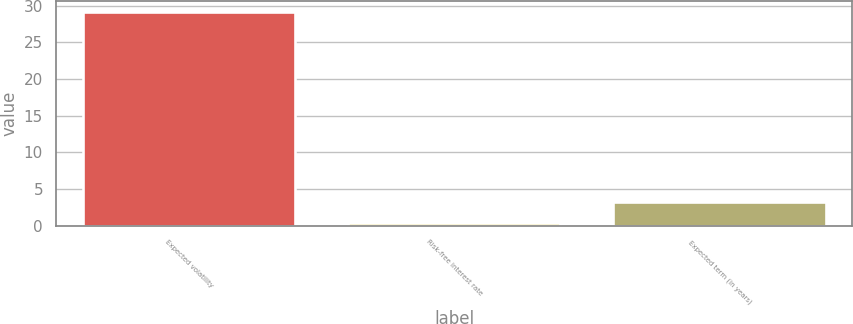<chart> <loc_0><loc_0><loc_500><loc_500><bar_chart><fcel>Expected volatility<fcel>Risk-free interest rate<fcel>Expected term (in years)<nl><fcel>29.18<fcel>0.42<fcel>3.3<nl></chart> 